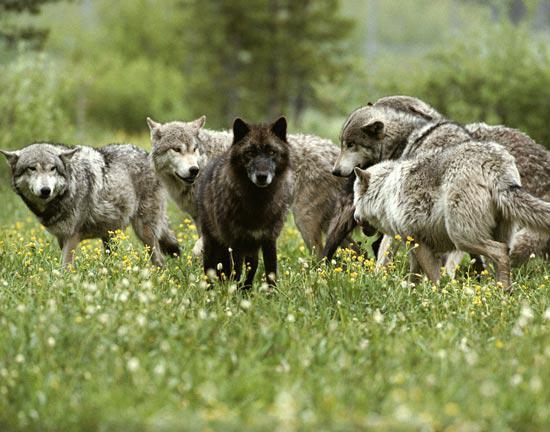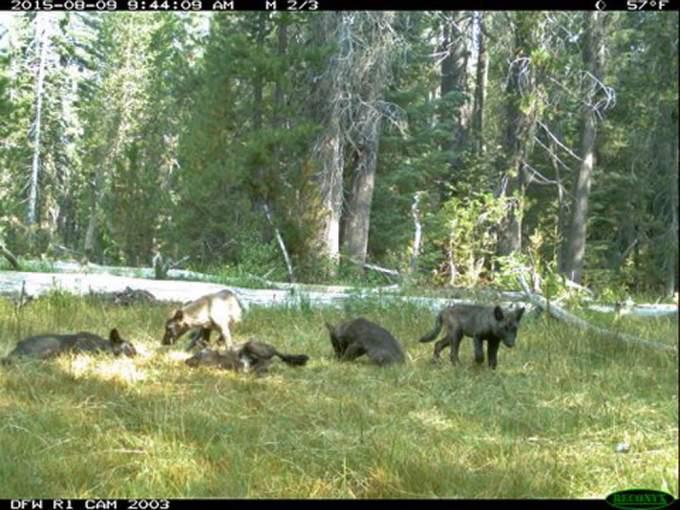The first image is the image on the left, the second image is the image on the right. Given the left and right images, does the statement "At least three animals are lying down in the grass in the image on the left." hold true? Answer yes or no. No. 